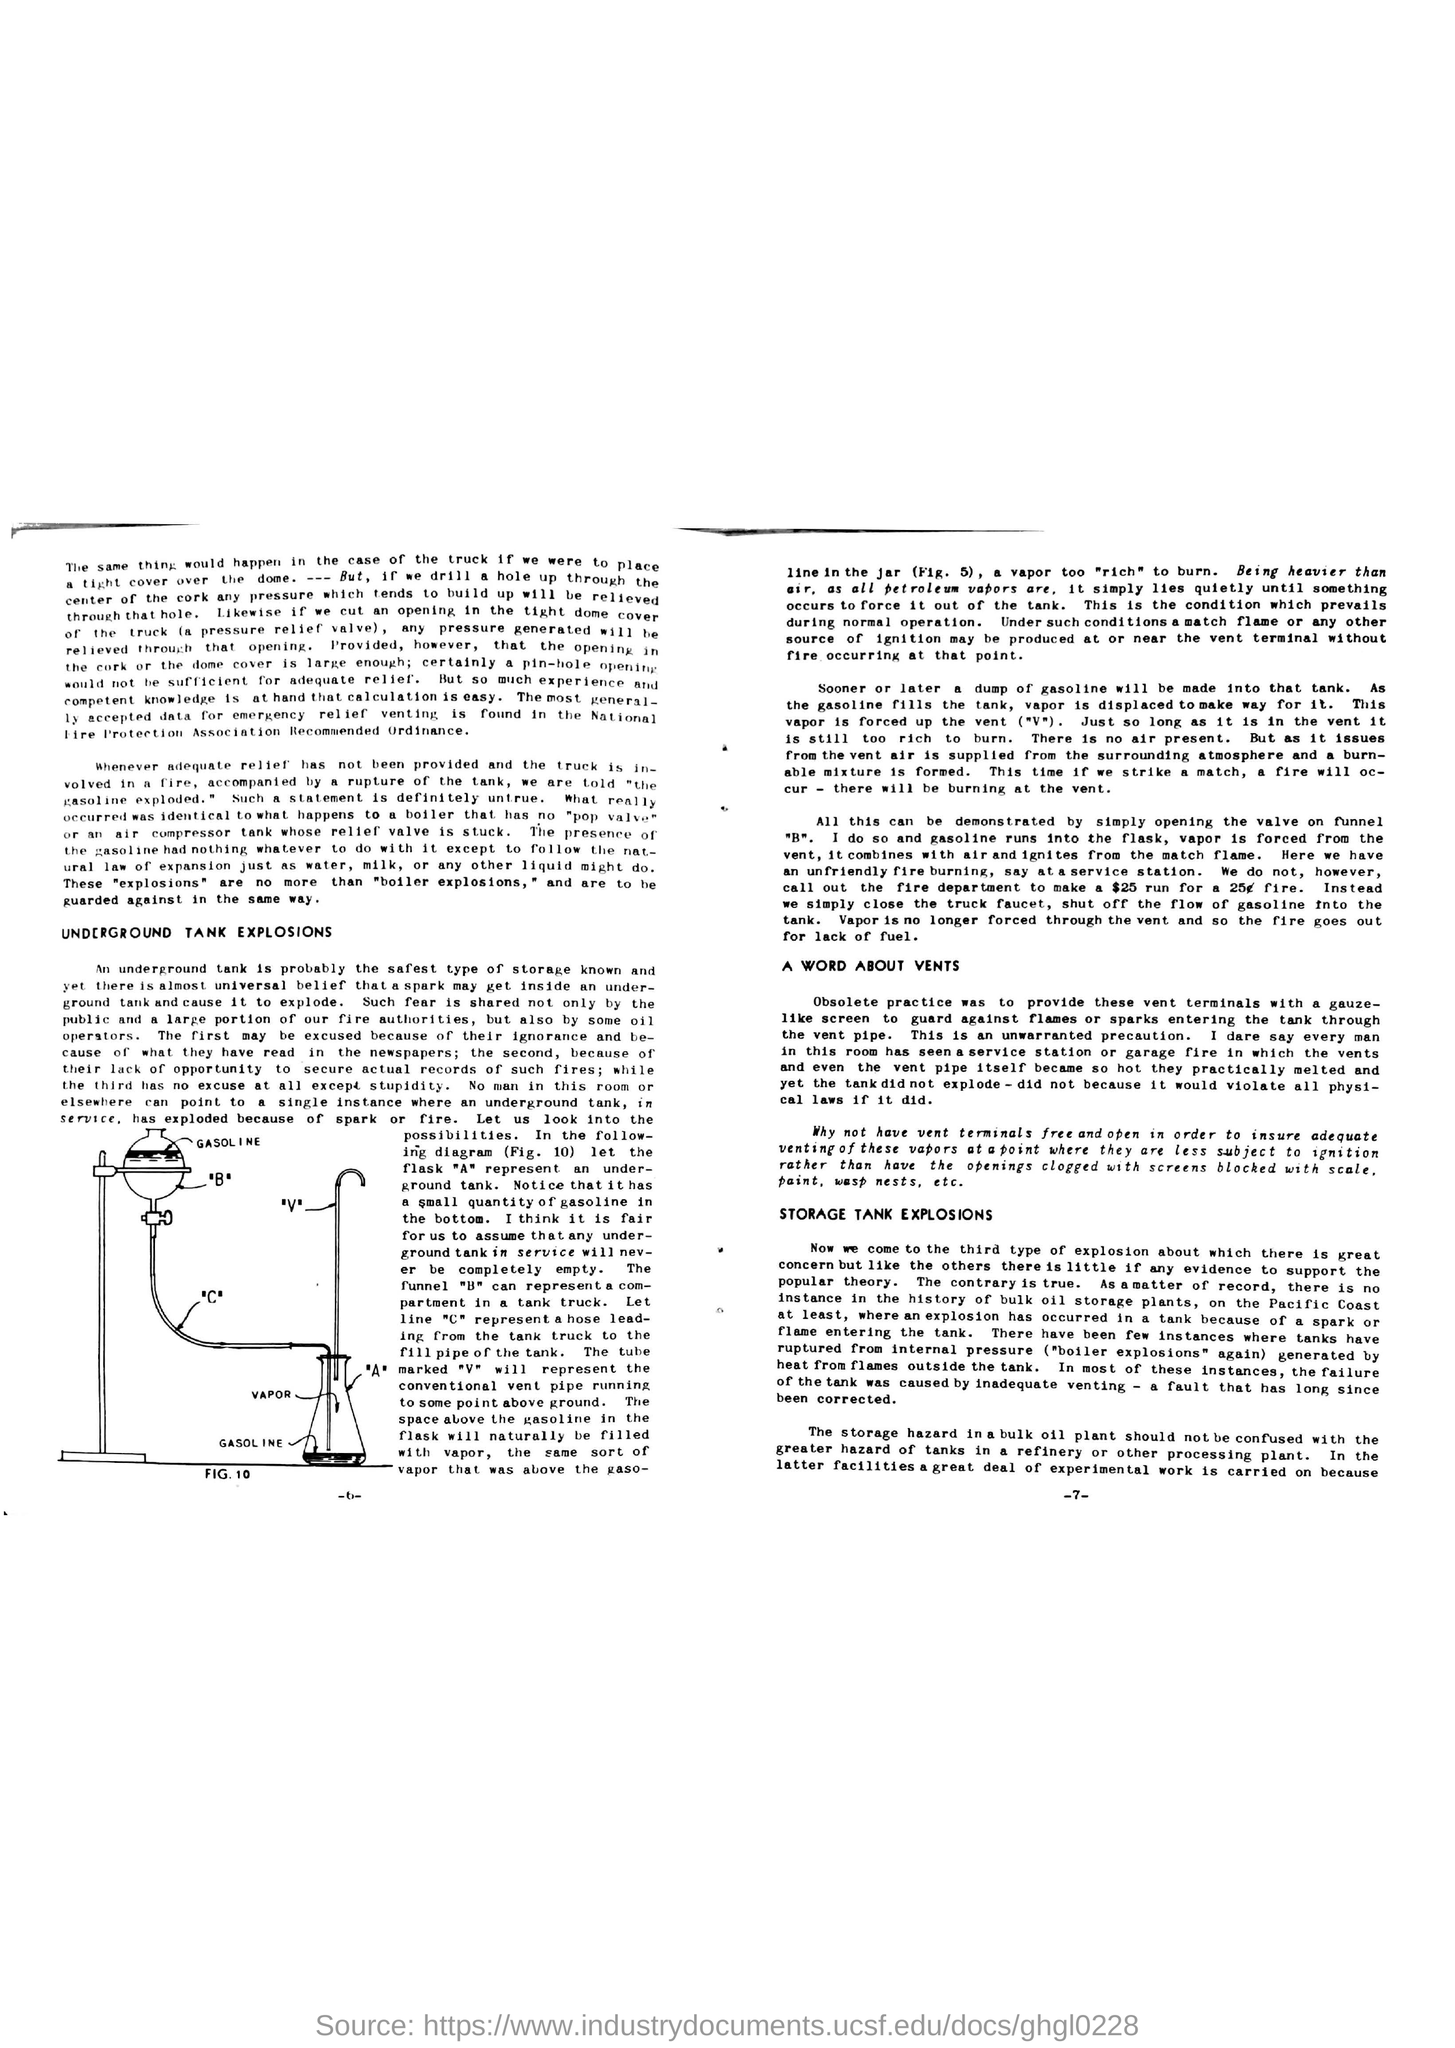Give some essential details in this illustration. Underground storage is considered the safest type of storage known. The most widely accepted source for emergency relief venting data can be found in the National Fire Protection Association's recommended ordinance. 